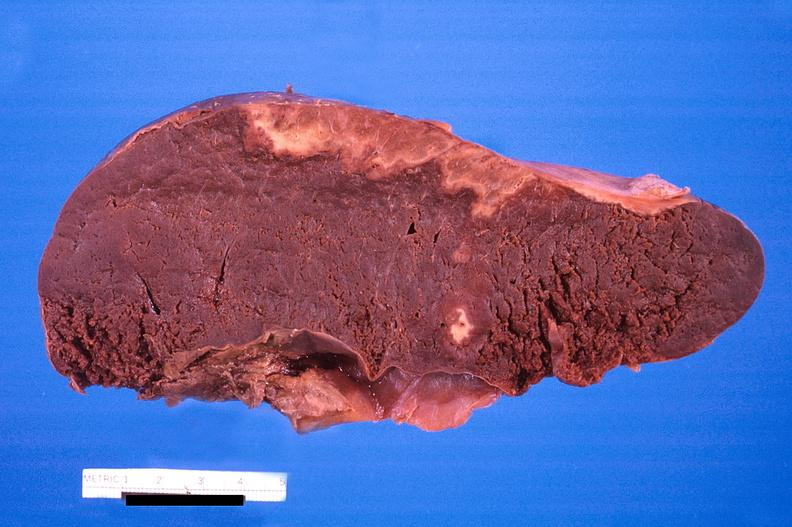what is spleen , infarcts , disseminated?
Answer the question using a single word or phrase. Intravascular coagulation 